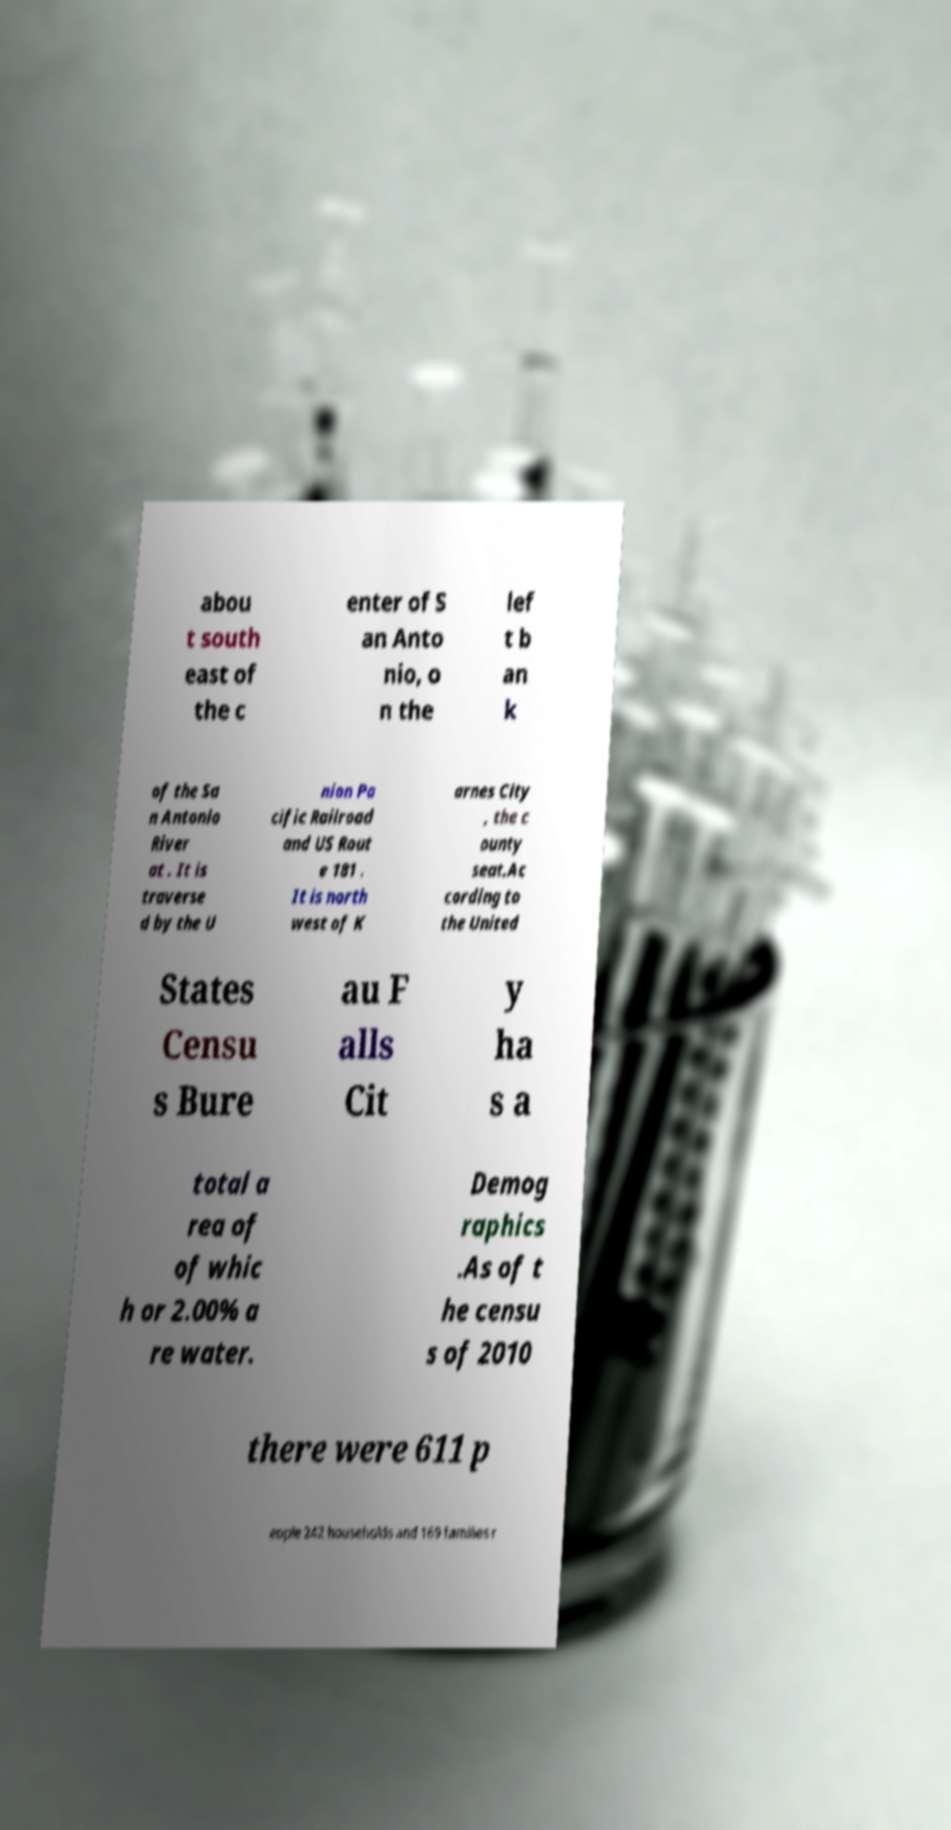Could you assist in decoding the text presented in this image and type it out clearly? abou t south east of the c enter of S an Anto nio, o n the lef t b an k of the Sa n Antonio River at . It is traverse d by the U nion Pa cific Railroad and US Rout e 181 . It is north west of K arnes City , the c ounty seat.Ac cording to the United States Censu s Bure au F alls Cit y ha s a total a rea of of whic h or 2.00% a re water. Demog raphics .As of t he censu s of 2010 there were 611 p eople 242 households and 169 families r 